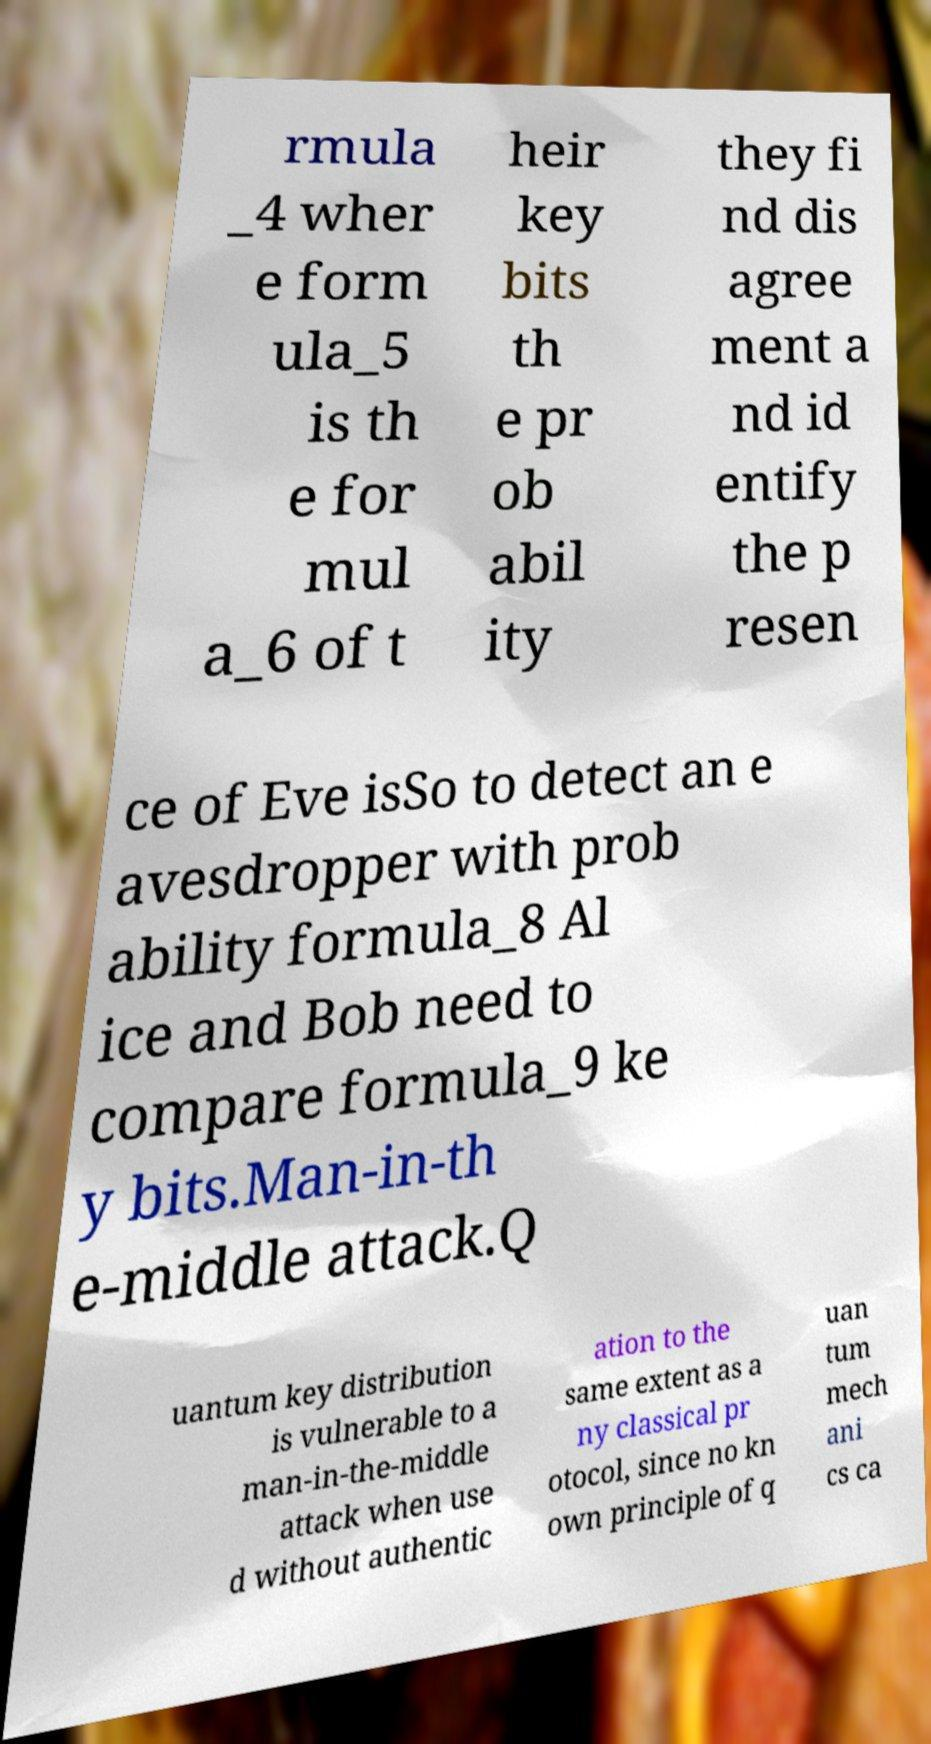There's text embedded in this image that I need extracted. Can you transcribe it verbatim? rmula _4 wher e form ula_5 is th e for mul a_6 of t heir key bits th e pr ob abil ity they fi nd dis agree ment a nd id entify the p resen ce of Eve isSo to detect an e avesdropper with prob ability formula_8 Al ice and Bob need to compare formula_9 ke y bits.Man-in-th e-middle attack.Q uantum key distribution is vulnerable to a man-in-the-middle attack when use d without authentic ation to the same extent as a ny classical pr otocol, since no kn own principle of q uan tum mech ani cs ca 